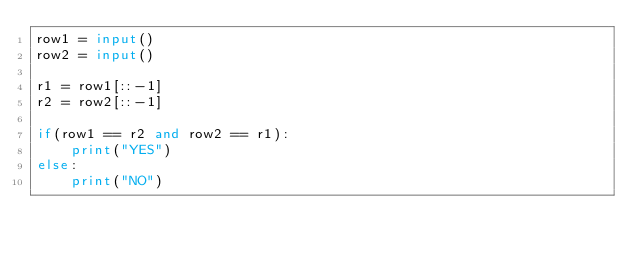Convert code to text. <code><loc_0><loc_0><loc_500><loc_500><_Python_>row1 = input()
row2 = input()

r1 = row1[::-1]
r2 = row2[::-1]

if(row1 == r2 and row2 == r1):
    print("YES")
else:
    print("NO")</code> 